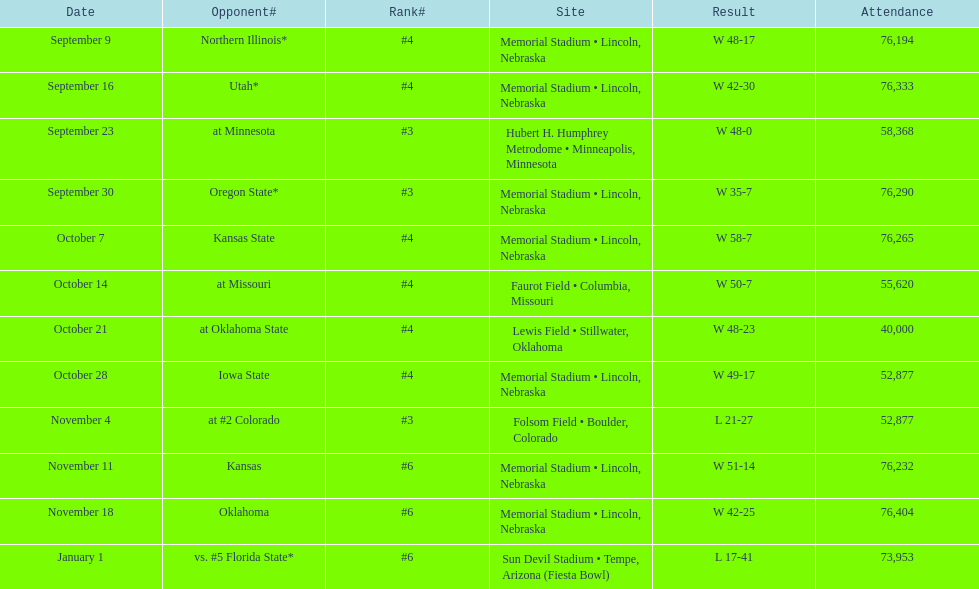Typically, how many instances was "w" recorded as the result? 10. 